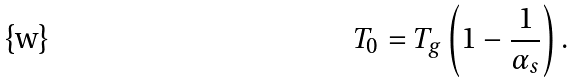<formula> <loc_0><loc_0><loc_500><loc_500>T _ { 0 } = T _ { g } \left ( 1 - \frac { 1 } { \alpha _ { s } } \right ) .</formula> 